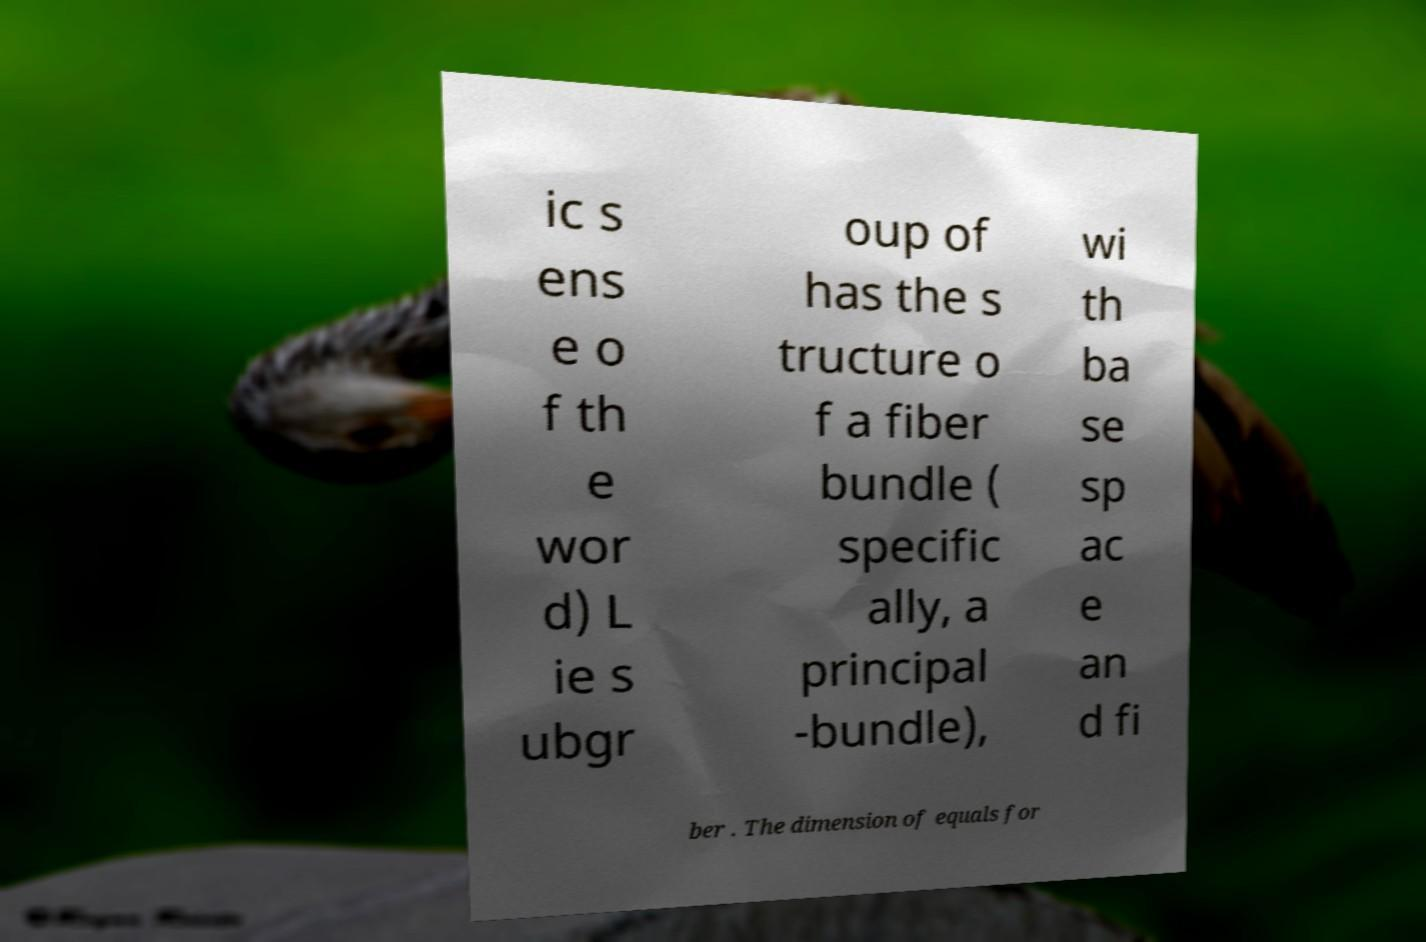Could you extract and type out the text from this image? ic s ens e o f th e wor d) L ie s ubgr oup of has the s tructure o f a fiber bundle ( specific ally, a principal -bundle), wi th ba se sp ac e an d fi ber . The dimension of equals for 